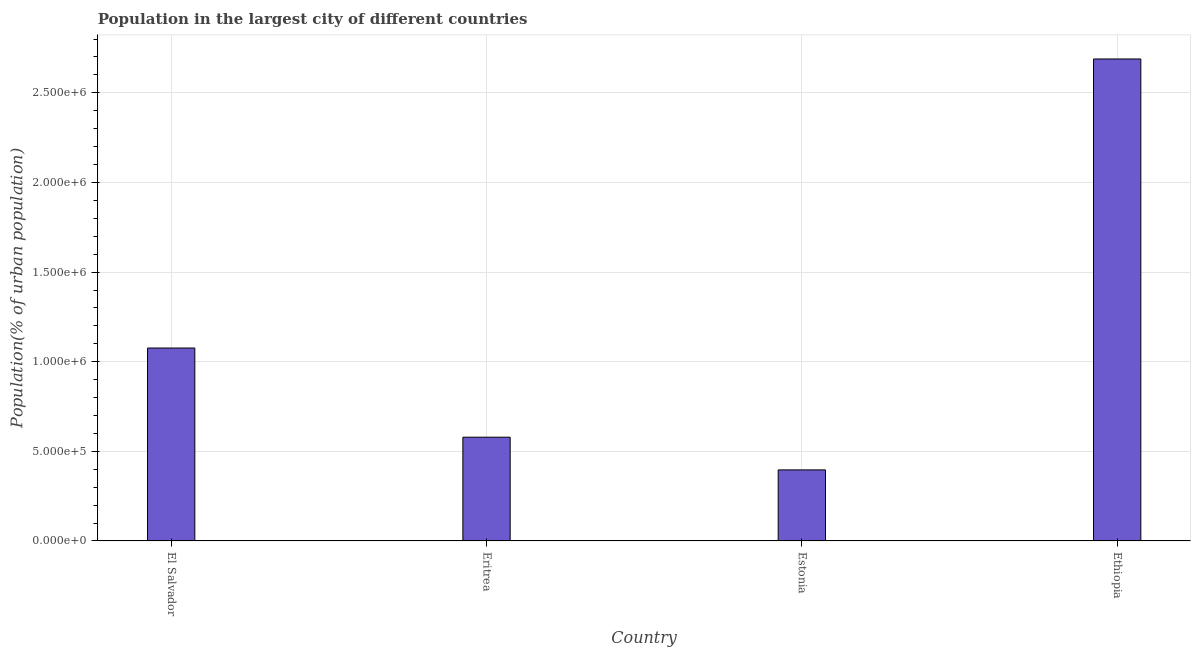What is the title of the graph?
Offer a very short reply. Population in the largest city of different countries. What is the label or title of the Y-axis?
Your answer should be compact. Population(% of urban population). What is the population in largest city in El Salvador?
Keep it short and to the point. 1.08e+06. Across all countries, what is the maximum population in largest city?
Offer a very short reply. 2.69e+06. Across all countries, what is the minimum population in largest city?
Provide a short and direct response. 3.97e+05. In which country was the population in largest city maximum?
Offer a terse response. Ethiopia. In which country was the population in largest city minimum?
Provide a succinct answer. Estonia. What is the sum of the population in largest city?
Ensure brevity in your answer.  4.74e+06. What is the difference between the population in largest city in Eritrea and Ethiopia?
Your response must be concise. -2.11e+06. What is the average population in largest city per country?
Make the answer very short. 1.19e+06. What is the median population in largest city?
Make the answer very short. 8.28e+05. What is the ratio of the population in largest city in Eritrea to that in Estonia?
Make the answer very short. 1.46. What is the difference between the highest and the second highest population in largest city?
Offer a very short reply. 1.61e+06. What is the difference between the highest and the lowest population in largest city?
Offer a terse response. 2.29e+06. In how many countries, is the population in largest city greater than the average population in largest city taken over all countries?
Your answer should be very brief. 1. How many bars are there?
Keep it short and to the point. 4. Are all the bars in the graph horizontal?
Ensure brevity in your answer.  No. Are the values on the major ticks of Y-axis written in scientific E-notation?
Ensure brevity in your answer.  Yes. What is the Population(% of urban population) of El Salvador?
Your response must be concise. 1.08e+06. What is the Population(% of urban population) of Eritrea?
Make the answer very short. 5.79e+05. What is the Population(% of urban population) of Estonia?
Your answer should be very brief. 3.97e+05. What is the Population(% of urban population) in Ethiopia?
Your answer should be very brief. 2.69e+06. What is the difference between the Population(% of urban population) in El Salvador and Eritrea?
Your response must be concise. 4.97e+05. What is the difference between the Population(% of urban population) in El Salvador and Estonia?
Your answer should be very brief. 6.80e+05. What is the difference between the Population(% of urban population) in El Salvador and Ethiopia?
Your response must be concise. -1.61e+06. What is the difference between the Population(% of urban population) in Eritrea and Estonia?
Provide a succinct answer. 1.82e+05. What is the difference between the Population(% of urban population) in Eritrea and Ethiopia?
Provide a short and direct response. -2.11e+06. What is the difference between the Population(% of urban population) in Estonia and Ethiopia?
Offer a terse response. -2.29e+06. What is the ratio of the Population(% of urban population) in El Salvador to that in Eritrea?
Ensure brevity in your answer.  1.86. What is the ratio of the Population(% of urban population) in El Salvador to that in Estonia?
Your response must be concise. 2.71. What is the ratio of the Population(% of urban population) in El Salvador to that in Ethiopia?
Make the answer very short. 0.4. What is the ratio of the Population(% of urban population) in Eritrea to that in Estonia?
Your response must be concise. 1.46. What is the ratio of the Population(% of urban population) in Eritrea to that in Ethiopia?
Provide a short and direct response. 0.21. What is the ratio of the Population(% of urban population) in Estonia to that in Ethiopia?
Your answer should be very brief. 0.15. 